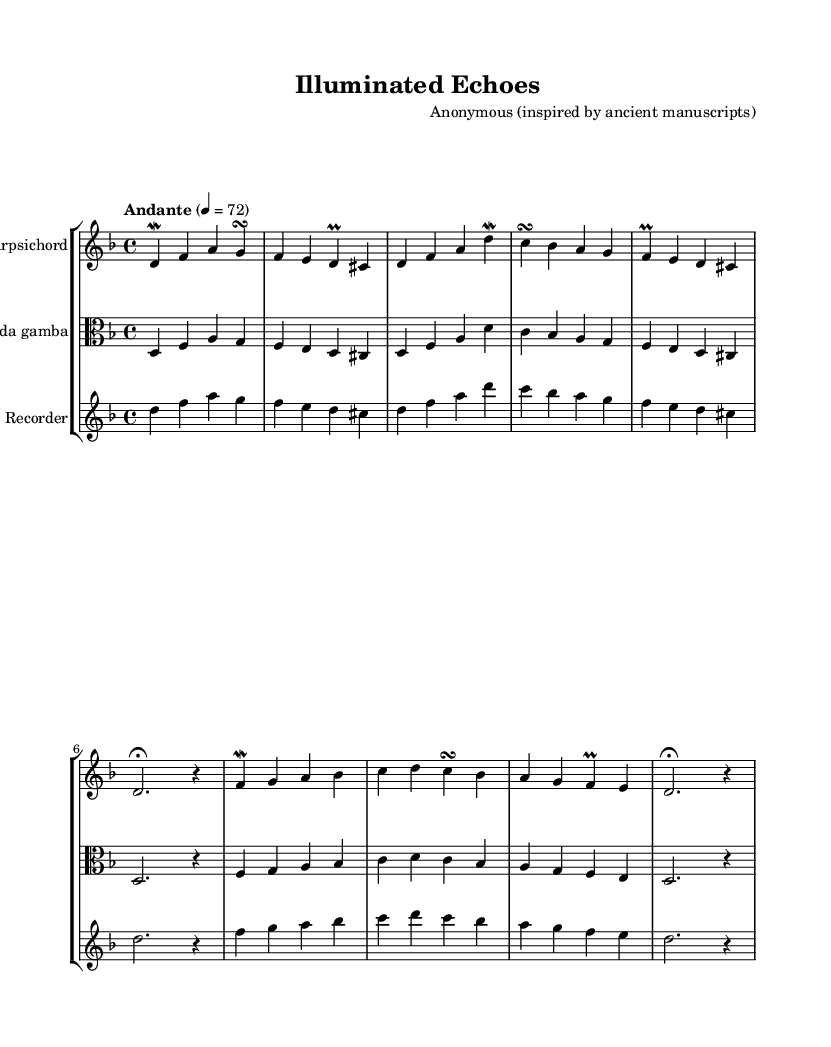What is the key signature of this music? The key signature indicates the tonality of a piece. The sheet music shows two flats, which corresponds to the key of D minor.
Answer: D minor What is the time signature of this music? The time signature is indicated at the beginning of the piece. The sheet music displays a 4 over 4, indicating the piece is structured in common time.
Answer: 4/4 What is the tempo marking of this piece? The tempo marking is given at the beginning of the music. It states "Andante" with a metronome marking of 72 beats per minute, indicating a moderately slow tempo.
Answer: Andante How many measures are there in total in the piece? By counting each grouping of notes in the system, the music has a total of eight measures from the beginning to the end.
Answer: Eight Which instruments are featured in this composition? The score contains three distinct staffs, each labeled with an instrument name. The instruments present are Harpsichord, Viola da gamba, and Recorder.
Answer: Harpsichord, Viola da gamba, Recorder What melodic ornament is used prominently in the harpsichord part? Upon examining the harpsichord line, we can observe the frequent use of mordents and turns as part of the melody's embellishments.
Answer: Mordent Which musical technique is evident in the viola part? The viola part exhibits a consistent melodic line that complements the harpsichord, and its phrasing indicates the use of embellishments, seen in the use of both pitches and rhythmic values.
Answer: Embellishments 